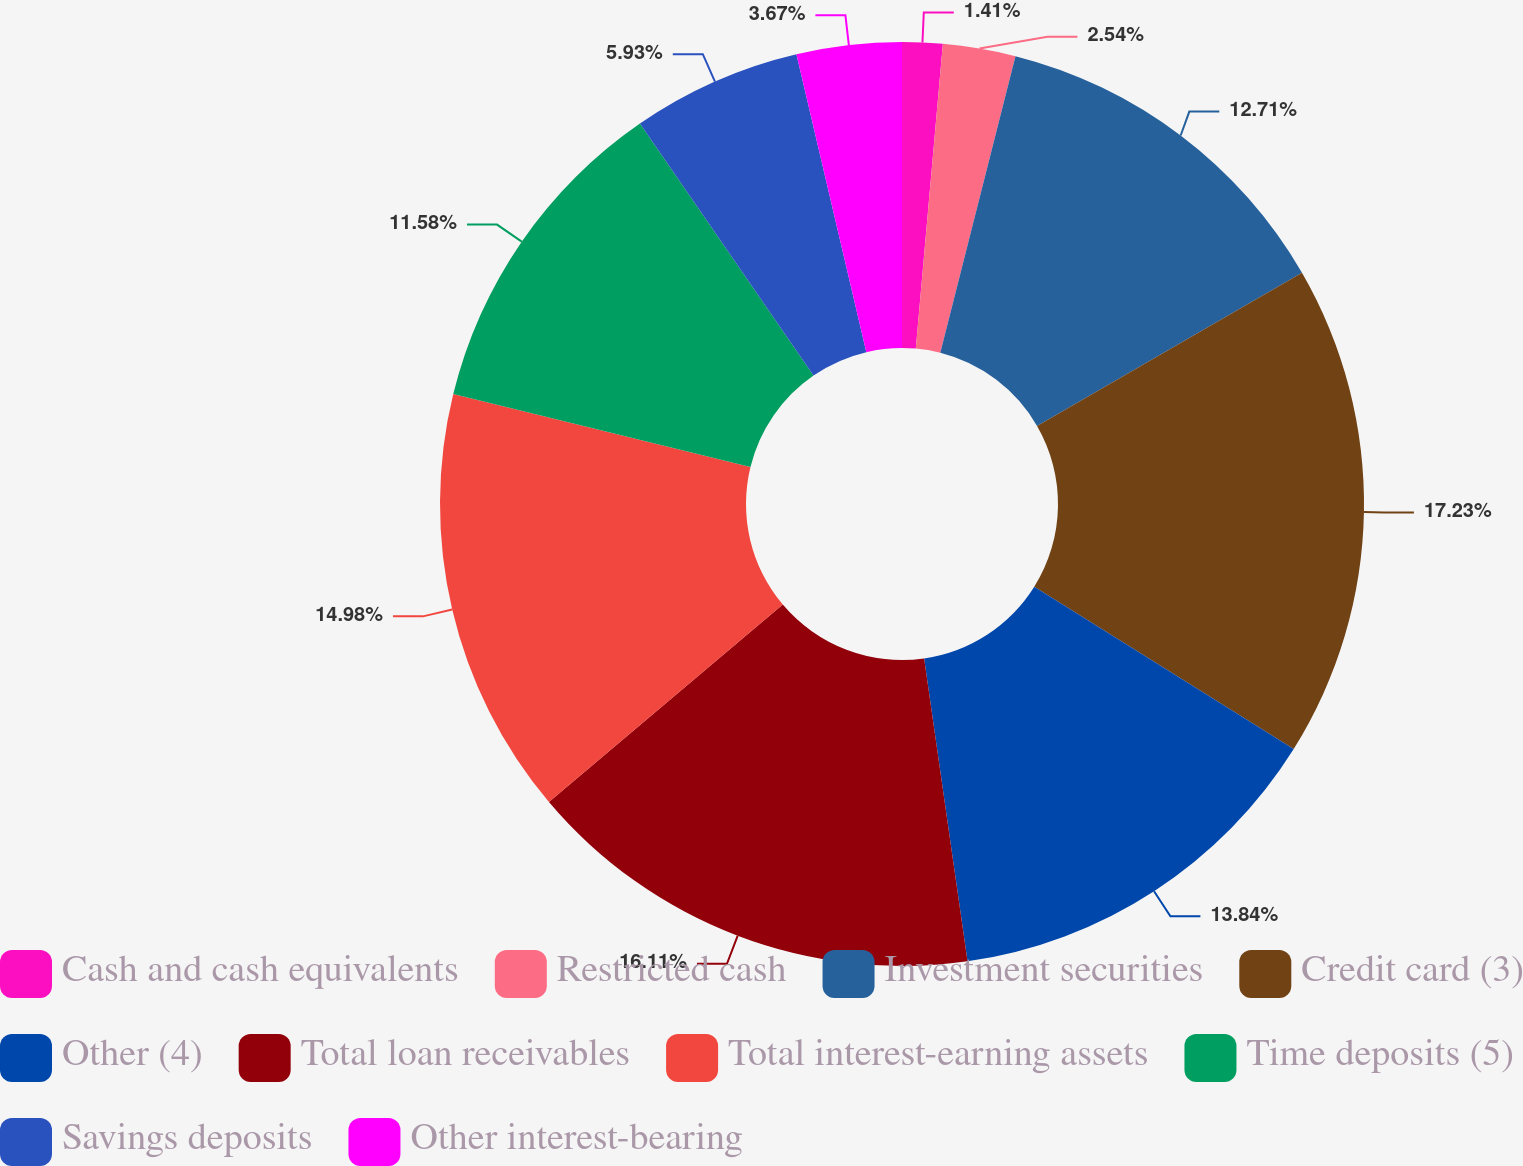<chart> <loc_0><loc_0><loc_500><loc_500><pie_chart><fcel>Cash and cash equivalents<fcel>Restricted cash<fcel>Investment securities<fcel>Credit card (3)<fcel>Other (4)<fcel>Total loan receivables<fcel>Total interest-earning assets<fcel>Time deposits (5)<fcel>Savings deposits<fcel>Other interest-bearing<nl><fcel>1.41%<fcel>2.54%<fcel>12.71%<fcel>17.24%<fcel>13.84%<fcel>16.11%<fcel>14.98%<fcel>11.58%<fcel>5.93%<fcel>3.67%<nl></chart> 